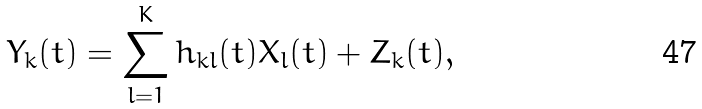<formula> <loc_0><loc_0><loc_500><loc_500>Y _ { k } ( t ) = \sum _ { l = 1 } ^ { K } h _ { k l } ( t ) X _ { l } ( t ) + Z _ { k } ( t ) ,</formula> 